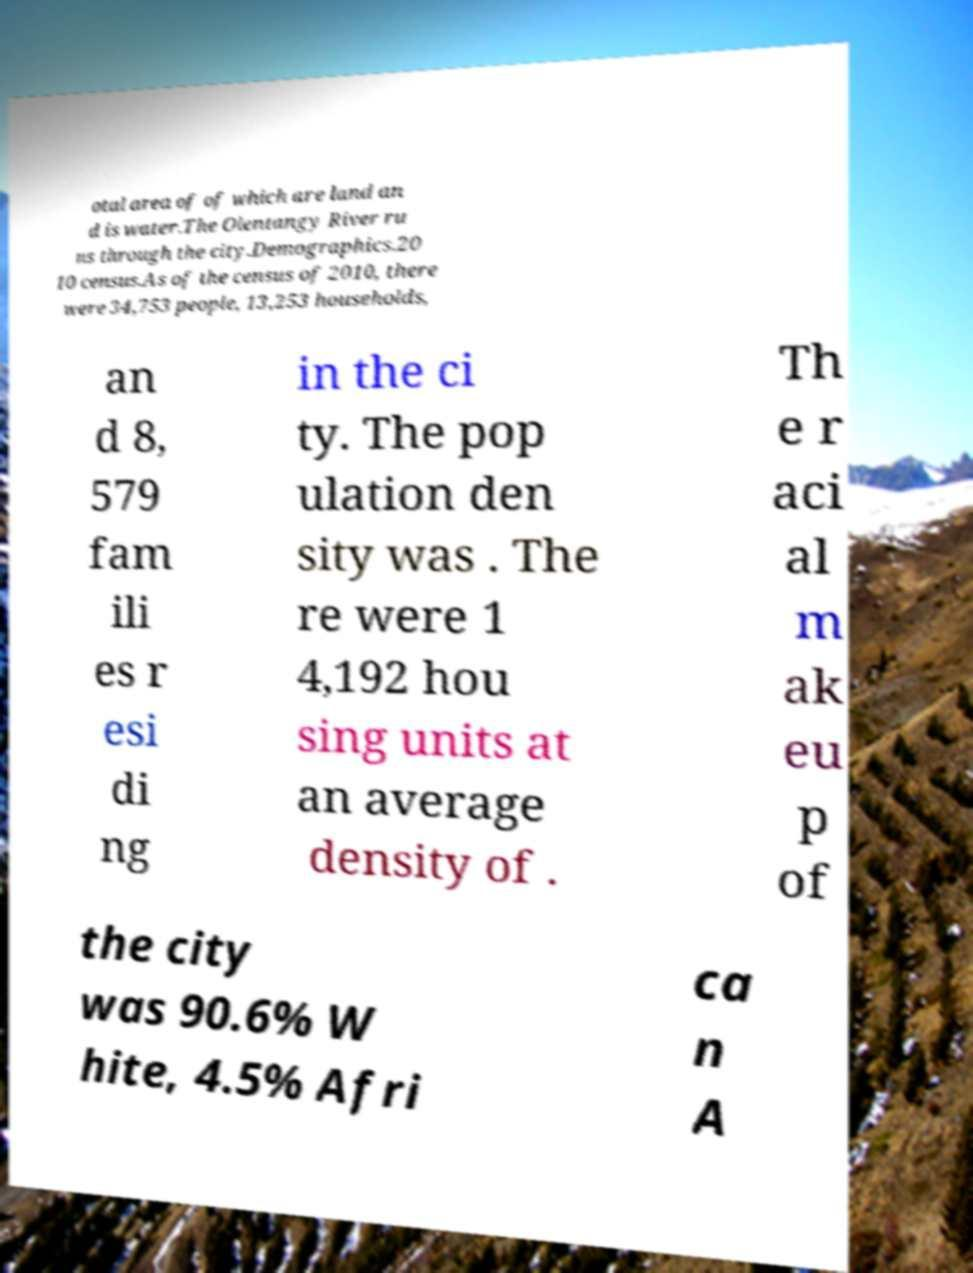I need the written content from this picture converted into text. Can you do that? otal area of of which are land an d is water.The Olentangy River ru ns through the city.Demographics.20 10 census.As of the census of 2010, there were 34,753 people, 13,253 households, an d 8, 579 fam ili es r esi di ng in the ci ty. The pop ulation den sity was . The re were 1 4,192 hou sing units at an average density of . Th e r aci al m ak eu p of the city was 90.6% W hite, 4.5% Afri ca n A 